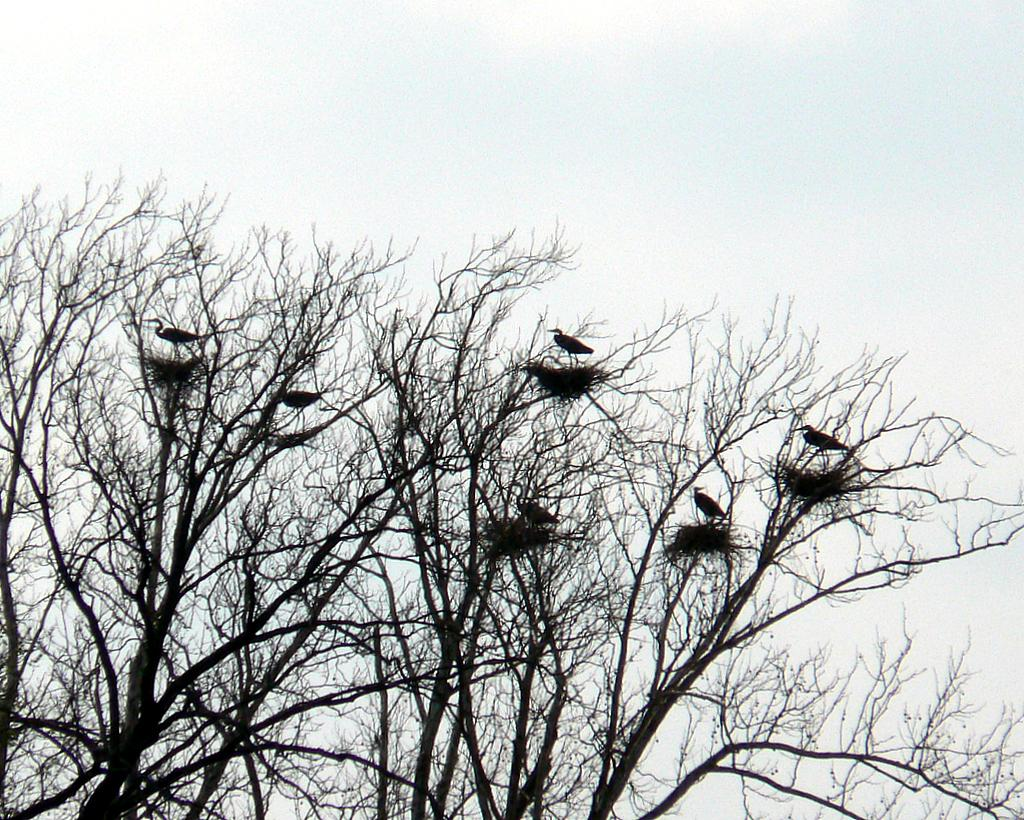What type of plant can be seen in the image? There is a tree in the image. What is on the tree? Birds are present on the tree. What is visible in the background of the image? There is a sky visible in the image. What type of prose can be seen on the tree? There is no prose present on the tree; it is a natural object with birds on it. 